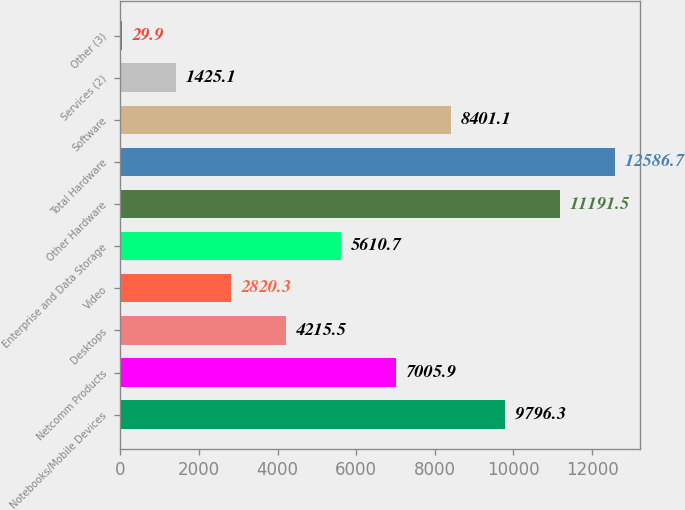<chart> <loc_0><loc_0><loc_500><loc_500><bar_chart><fcel>Notebooks/Mobile Devices<fcel>Netcomm Products<fcel>Desktops<fcel>Video<fcel>Enterprise and Data Storage<fcel>Other Hardware<fcel>Total Hardware<fcel>Software<fcel>Services (2)<fcel>Other (3)<nl><fcel>9796.3<fcel>7005.9<fcel>4215.5<fcel>2820.3<fcel>5610.7<fcel>11191.5<fcel>12586.7<fcel>8401.1<fcel>1425.1<fcel>29.9<nl></chart> 